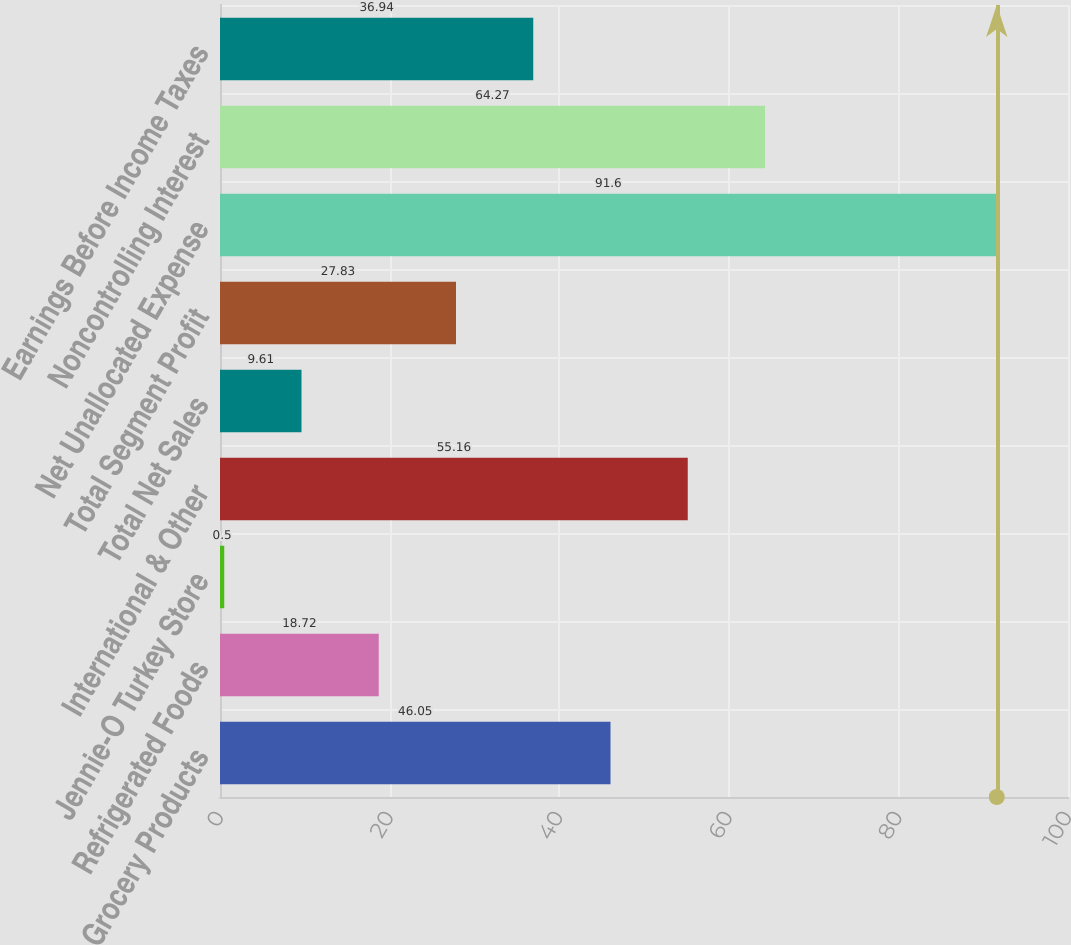<chart> <loc_0><loc_0><loc_500><loc_500><bar_chart><fcel>Grocery Products<fcel>Refrigerated Foods<fcel>Jennie-O Turkey Store<fcel>International & Other<fcel>Total Net Sales<fcel>Total Segment Profit<fcel>Net Unallocated Expense<fcel>Noncontrolling Interest<fcel>Earnings Before Income Taxes<nl><fcel>46.05<fcel>18.72<fcel>0.5<fcel>55.16<fcel>9.61<fcel>27.83<fcel>91.6<fcel>64.27<fcel>36.94<nl></chart> 